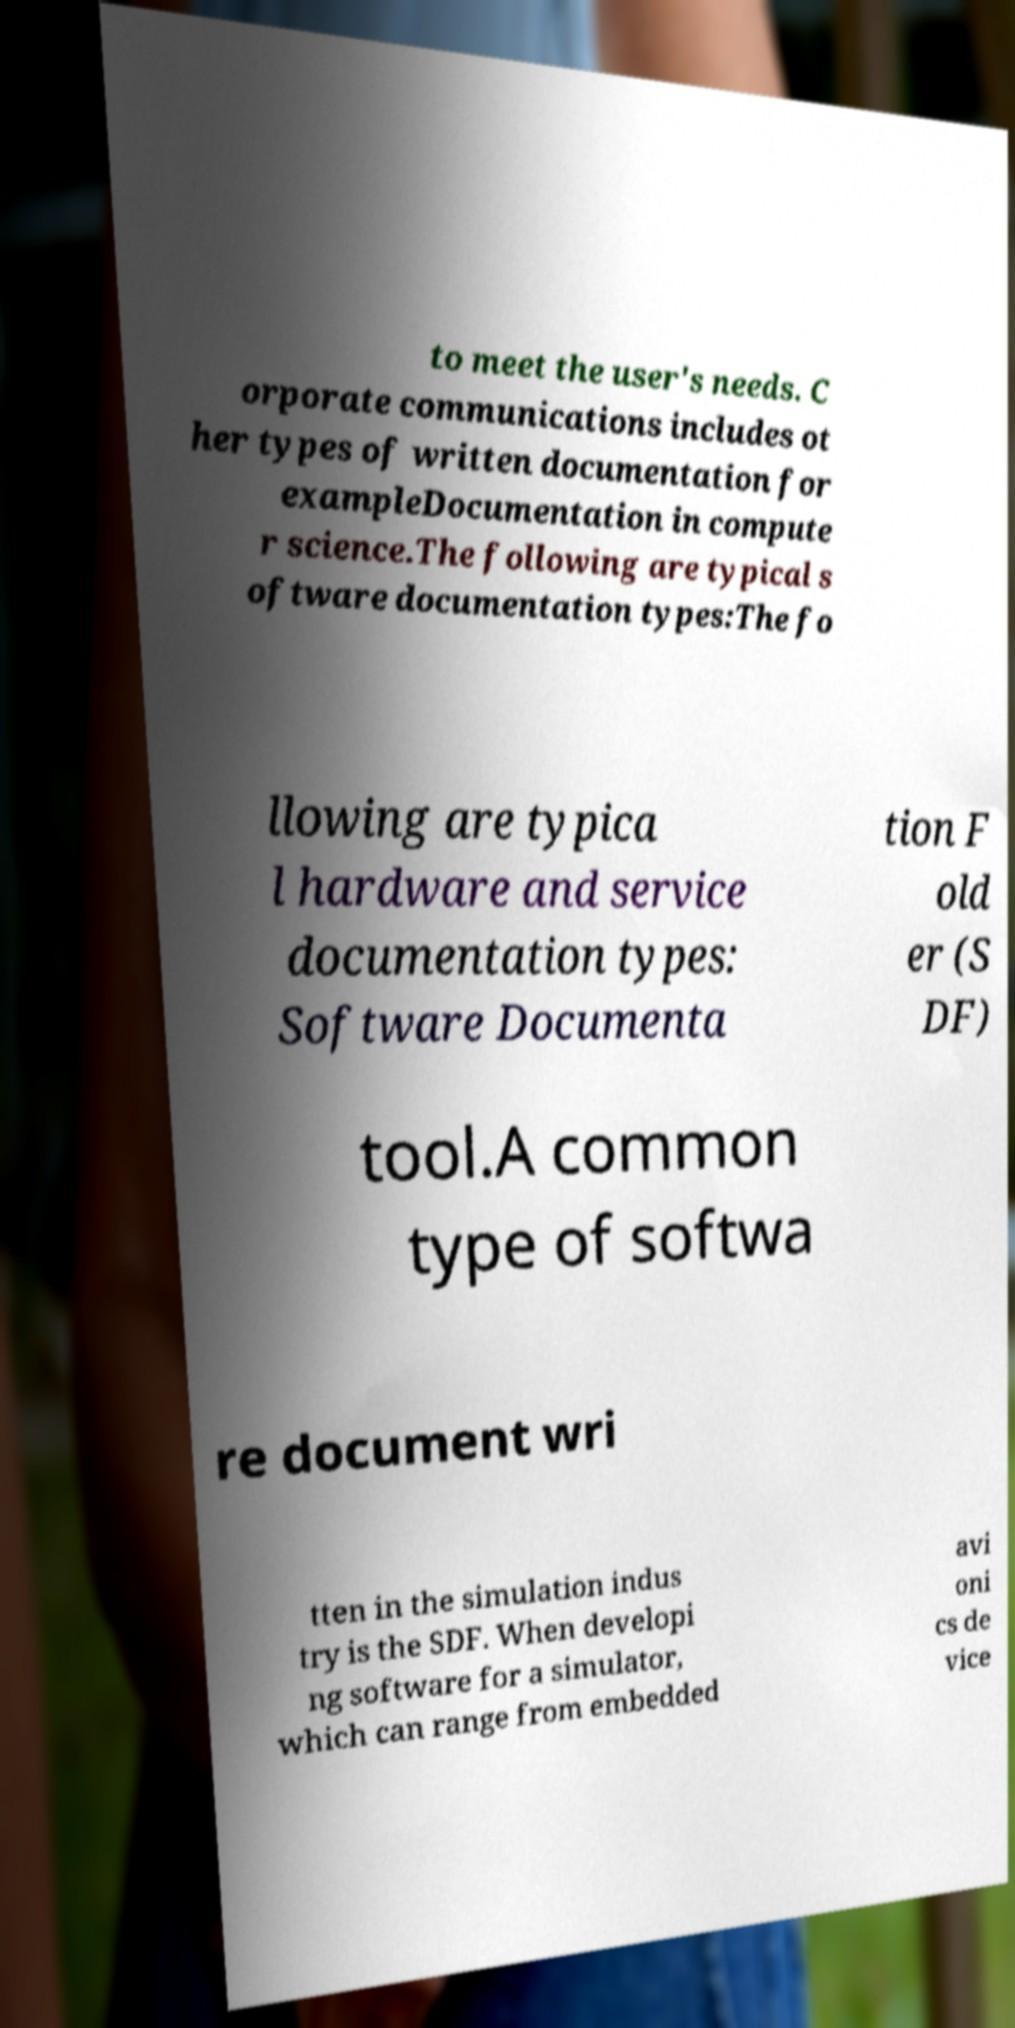Could you assist in decoding the text presented in this image and type it out clearly? to meet the user's needs. C orporate communications includes ot her types of written documentation for exampleDocumentation in compute r science.The following are typical s oftware documentation types:The fo llowing are typica l hardware and service documentation types: Software Documenta tion F old er (S DF) tool.A common type of softwa re document wri tten in the simulation indus try is the SDF. When developi ng software for a simulator, which can range from embedded avi oni cs de vice 